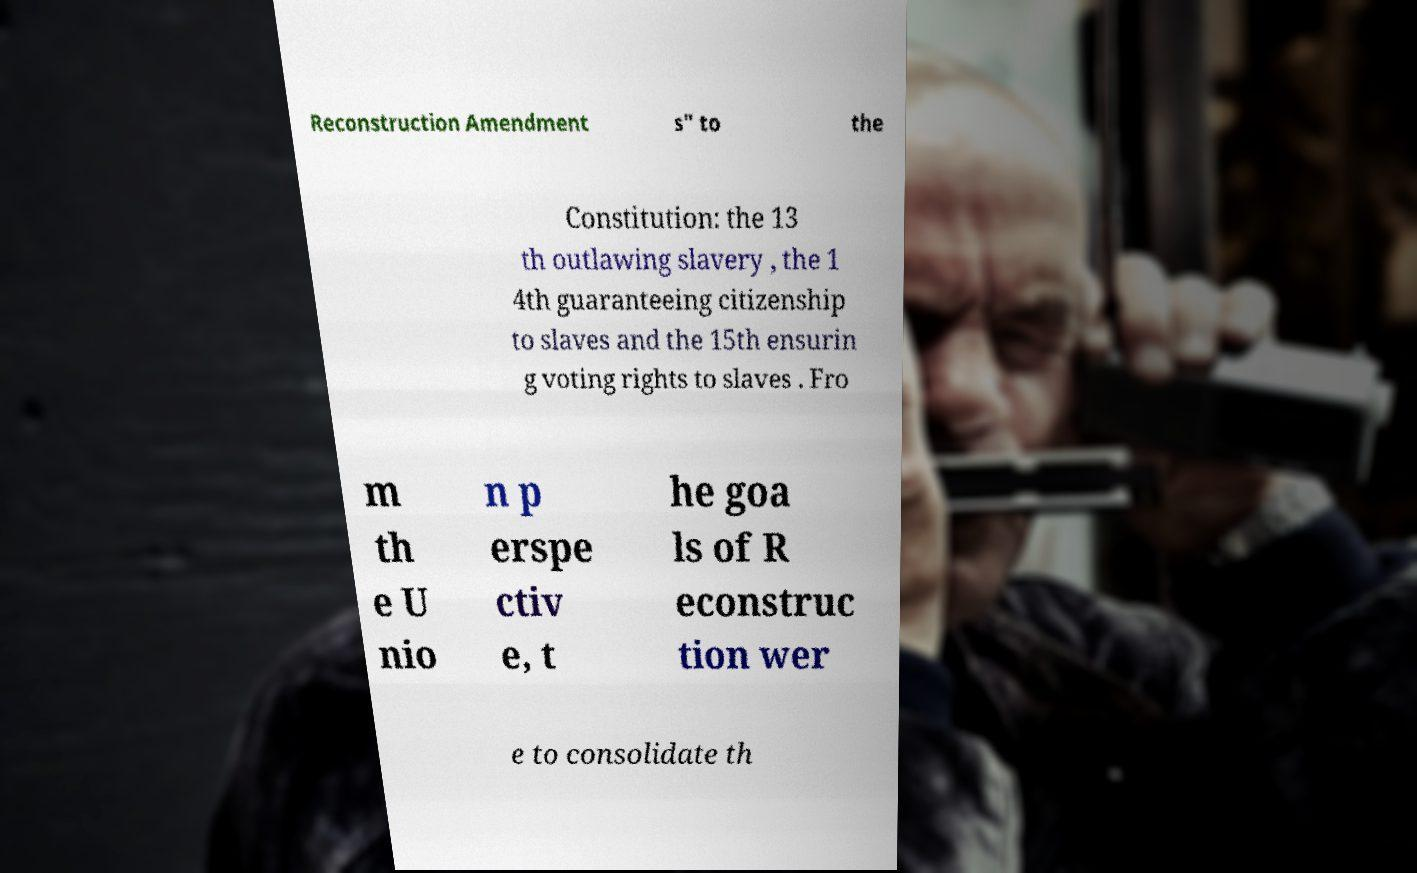Could you assist in decoding the text presented in this image and type it out clearly? Reconstruction Amendment s" to the Constitution: the 13 th outlawing slavery , the 1 4th guaranteeing citizenship to slaves and the 15th ensurin g voting rights to slaves . Fro m th e U nio n p erspe ctiv e, t he goa ls of R econstruc tion wer e to consolidate th 